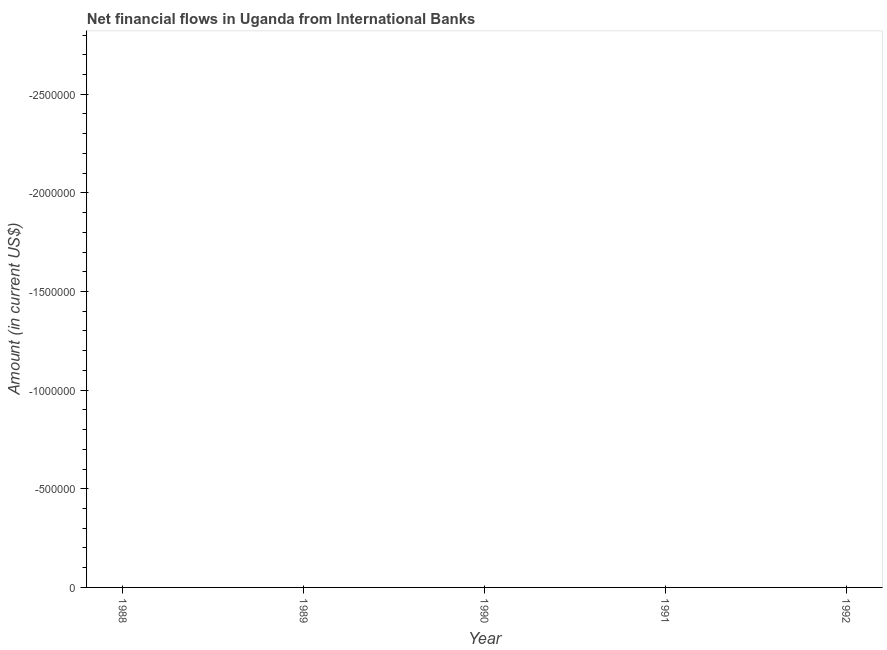What is the sum of the net financial flows from ibrd?
Provide a short and direct response. 0. In how many years, is the net financial flows from ibrd greater than the average net financial flows from ibrd taken over all years?
Offer a terse response. 0. Does the net financial flows from ibrd monotonically increase over the years?
Make the answer very short. No. What is the difference between two consecutive major ticks on the Y-axis?
Give a very brief answer. 5.00e+05. Are the values on the major ticks of Y-axis written in scientific E-notation?
Offer a very short reply. No. Does the graph contain any zero values?
Ensure brevity in your answer.  Yes. Does the graph contain grids?
Make the answer very short. No. What is the title of the graph?
Offer a terse response. Net financial flows in Uganda from International Banks. What is the label or title of the X-axis?
Your answer should be very brief. Year. What is the label or title of the Y-axis?
Provide a short and direct response. Amount (in current US$). What is the Amount (in current US$) in 1988?
Provide a succinct answer. 0. What is the Amount (in current US$) in 1992?
Your response must be concise. 0. 